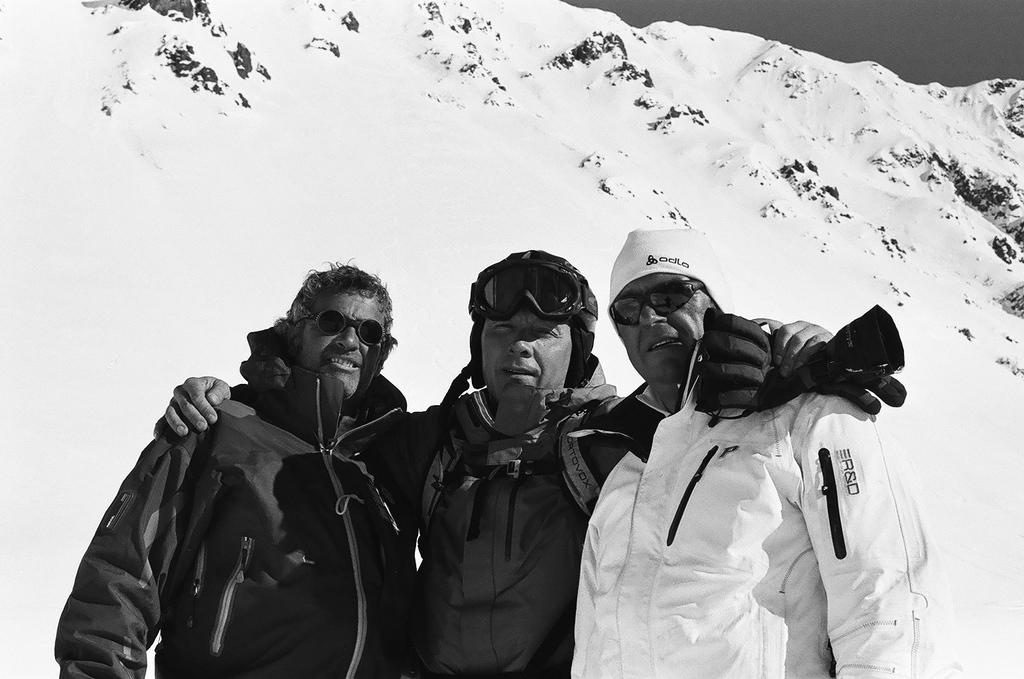How many people are in the image? There are three persons in the image. What are the people wearing on their heads? Each person is wearing goggles, and the person on the right side of the image is wearing a cap. What type of clothing are the people wearing on their upper bodies? Each person is wearing a jacket. What can be seen in the background of the image? There is a hill visible in the background of the image. What is the condition of the hill? The hill is covered with snow. Who is the creator of the hill in the image? The image does not provide information about the creator of the hill; it is a natural formation covered with snow. What type of punishment is being administered to the person on the left side of the image? There is no indication of punishment in the image; the people are simply wearing jackets and goggles, which suggests they might be engaging in an outdoor activity. 